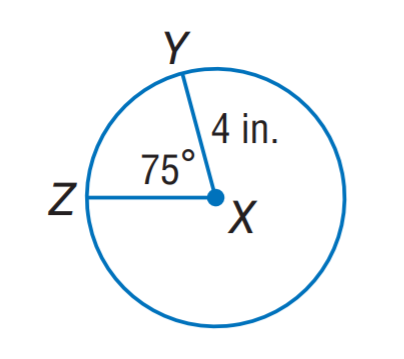Answer the mathemtical geometry problem and directly provide the correct option letter.
Question: Find the length of \widehat Z Y. Round to the nearest hundredth.
Choices: A: 3.76 B: 4.64 C: 5.24 D: 7.28 C 